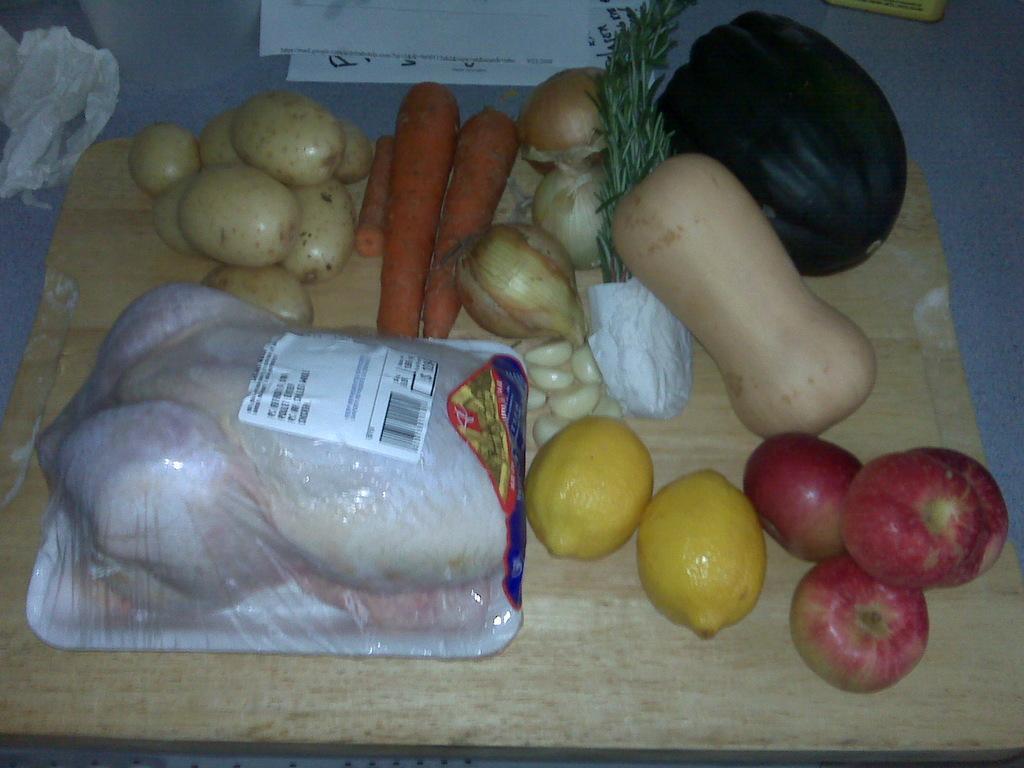Could you give a brief overview of what you see in this image? In this image we can see group of vegetables and fruits are placed on a tray along with meat are placed on the table. 